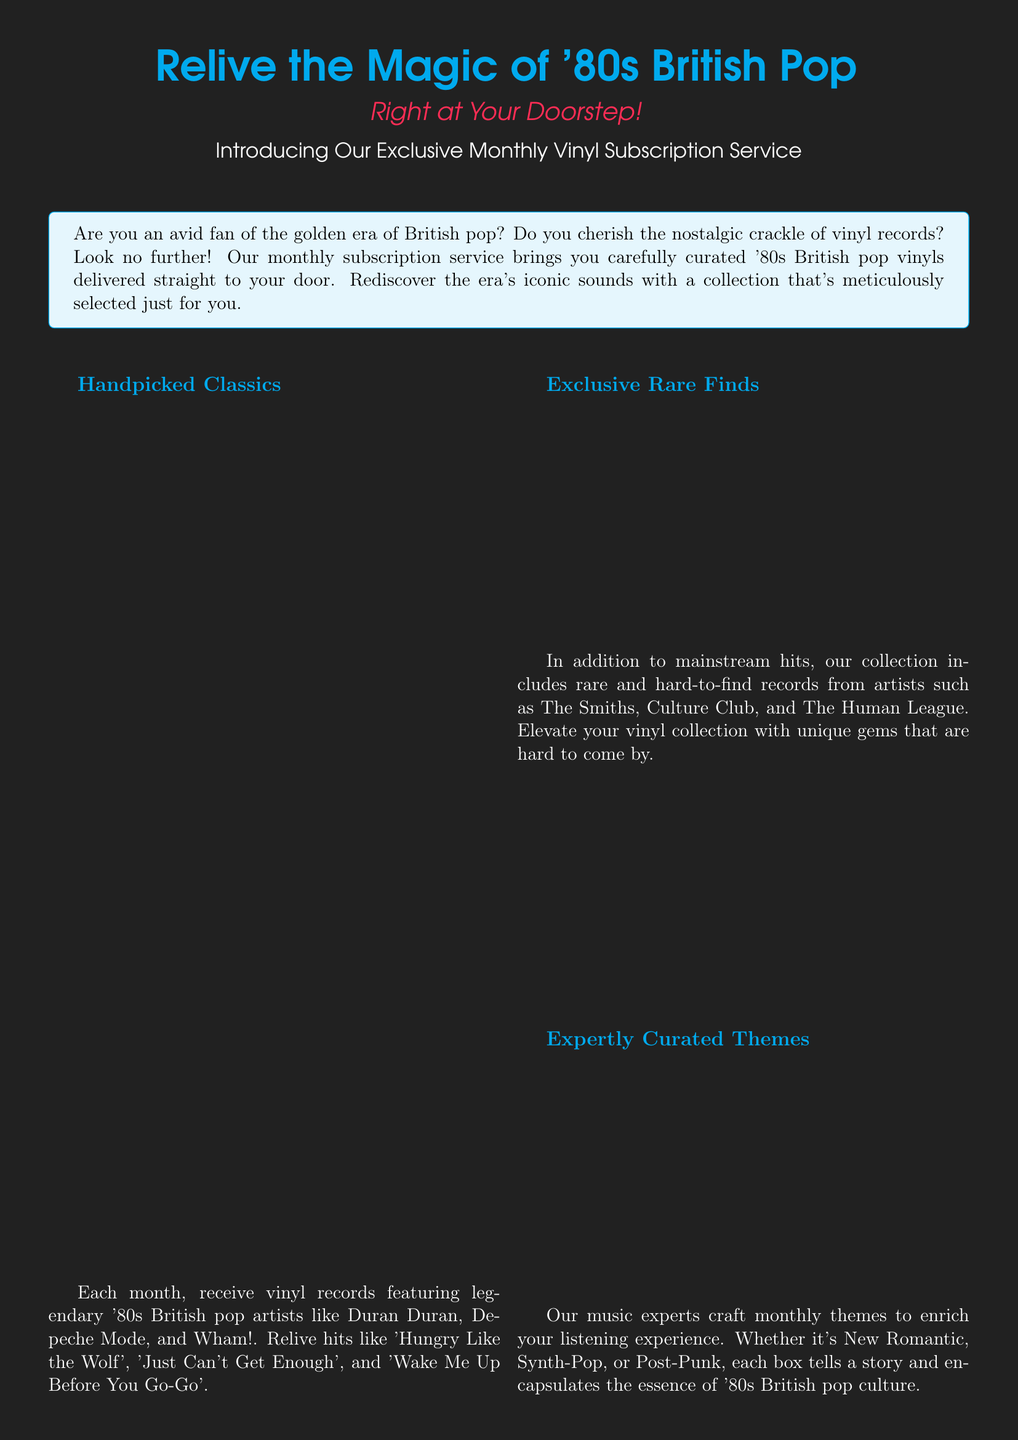What is the website for the subscription service? The document includes a section with contact information, including the website, which is stated as "www.80sBritishPopVinyls.com".
Answer: www.80sBritishPopVinyls.com Who is quoted in the testimonial? The testimonial in the document mentions a person named John Smith, who is identified as a music blogger.
Answer: John Smith What is included in the monthly subscription? The advertisement mentions that each month features carefully curated '80s British pop vinyls delivered.
Answer: Carefully curated '80s British pop vinyls Name one artist mentioned in the handpicked classics section. The document lists several artists, and one of them mentioned is Duran Duran.
Answer: Duran Duran What themes can be found in the subscription boxes? The document states that themes are crafted by music experts, and examples given include New Romantic, Synth-Pop, and Post-Punk.
Answer: New Romantic How are the vinyl records packaged? The advertisement emphasizes that the vinyls are packaged with care to ensure they arrive in pristine condition.
Answer: With care What type of music does the subscription focus on? The advertisement highlights that the subscription service focuses on '80s British pop music.
Answer: '80s British pop What is the phone number provided in the document? The contact information includes a phone number, which is "+44 20 1234 5678".
Answer: +44 20 1234 5678 What is the main appeal of the subscription service? The document appeals to fans by stating it brings nostalgic crackle of vinyl records directly to the fan's door.
Answer: Nostalgic crackle of vinyl records 